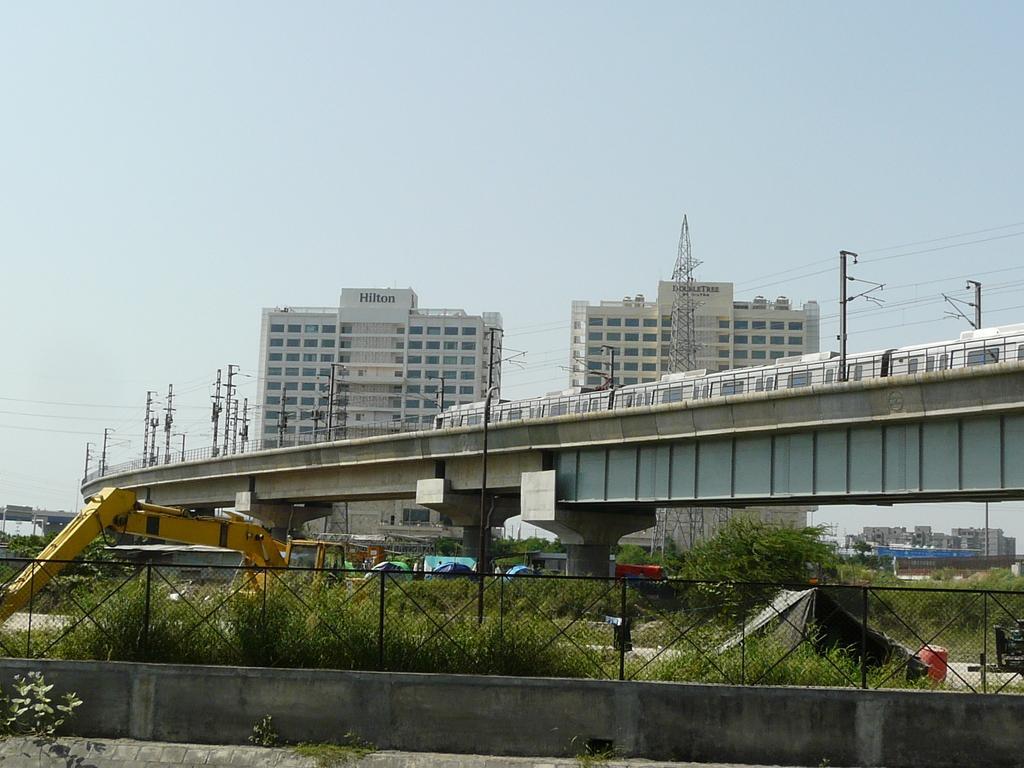Can you describe this image briefly? In this picture we can see building with windows and a railway track for metro rail with poles, traffic signals and below this railway track we have trees, fence, wall, crane and above this building we have sky and in front of the building there is a tower. 